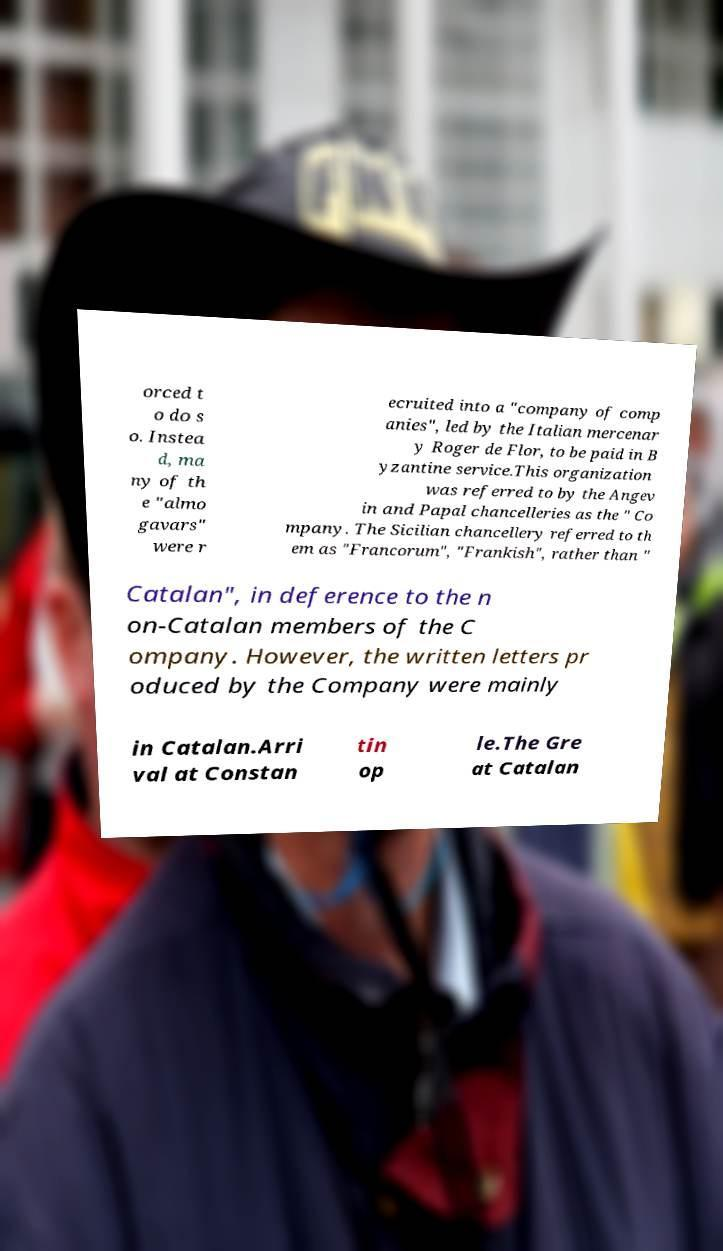Could you extract and type out the text from this image? orced t o do s o. Instea d, ma ny of th e "almo gavars" were r ecruited into a "company of comp anies", led by the Italian mercenar y Roger de Flor, to be paid in B yzantine service.This organization was referred to by the Angev in and Papal chancelleries as the " Co mpany. The Sicilian chancellery referred to th em as "Francorum", "Frankish", rather than " Catalan", in deference to the n on-Catalan members of the C ompany. However, the written letters pr oduced by the Company were mainly in Catalan.Arri val at Constan tin op le.The Gre at Catalan 